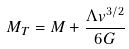<formula> <loc_0><loc_0><loc_500><loc_500>M _ { T } = M + \frac { \Lambda v ^ { 3 / 2 } } { 6 G }</formula> 